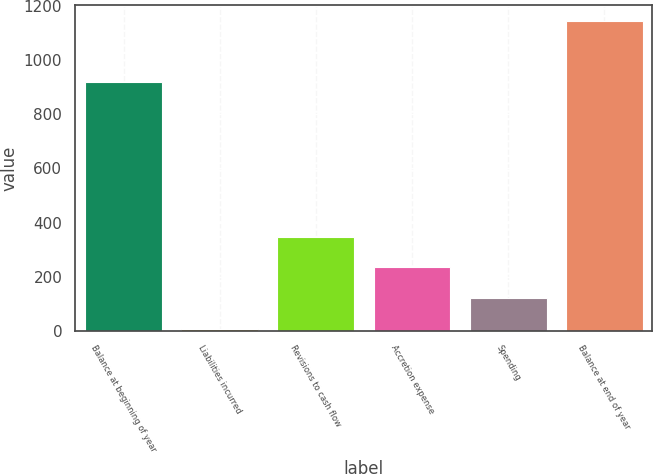Convert chart to OTSL. <chart><loc_0><loc_0><loc_500><loc_500><bar_chart><fcel>Balance at beginning of year<fcel>Liabilities incurred<fcel>Revisions to cash flow<fcel>Accretion expense<fcel>Spending<fcel>Balance at end of year<nl><fcel>921<fcel>6<fcel>348<fcel>234<fcel>120<fcel>1146<nl></chart> 